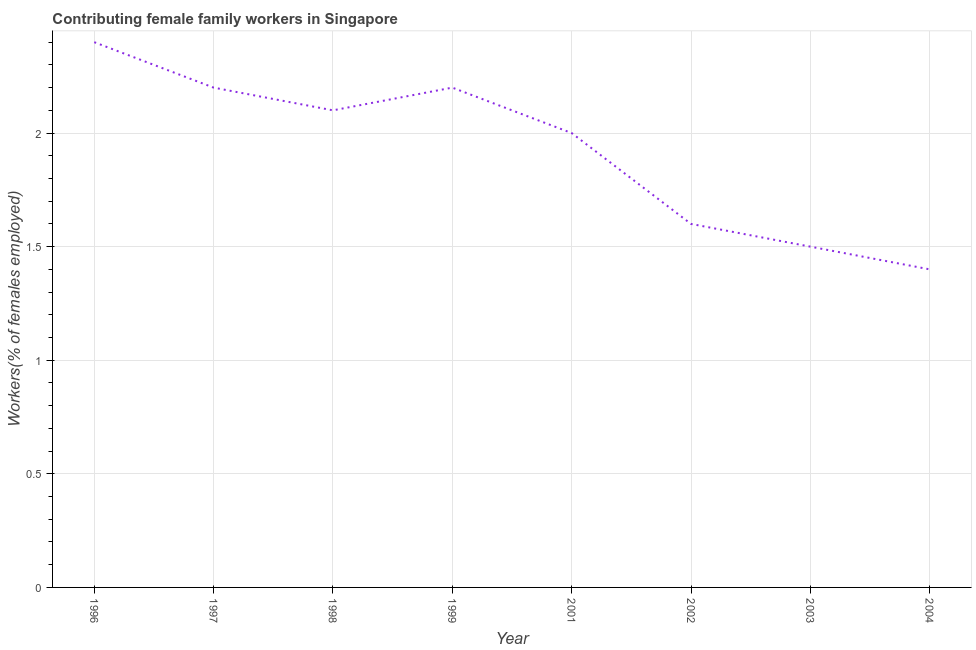What is the contributing female family workers in 1996?
Provide a short and direct response. 2.4. Across all years, what is the maximum contributing female family workers?
Your response must be concise. 2.4. Across all years, what is the minimum contributing female family workers?
Make the answer very short. 1.4. What is the sum of the contributing female family workers?
Give a very brief answer. 15.4. What is the difference between the contributing female family workers in 1997 and 1998?
Your response must be concise. 0.1. What is the average contributing female family workers per year?
Your answer should be very brief. 1.93. What is the median contributing female family workers?
Keep it short and to the point. 2.05. What is the ratio of the contributing female family workers in 1999 to that in 2001?
Offer a very short reply. 1.1. Is the contributing female family workers in 2001 less than that in 2003?
Your response must be concise. No. Is the difference between the contributing female family workers in 1998 and 2004 greater than the difference between any two years?
Provide a short and direct response. No. What is the difference between the highest and the second highest contributing female family workers?
Give a very brief answer. 0.2. What is the difference between the highest and the lowest contributing female family workers?
Offer a terse response. 1. Are the values on the major ticks of Y-axis written in scientific E-notation?
Provide a short and direct response. No. Does the graph contain grids?
Your answer should be very brief. Yes. What is the title of the graph?
Your response must be concise. Contributing female family workers in Singapore. What is the label or title of the X-axis?
Offer a very short reply. Year. What is the label or title of the Y-axis?
Offer a terse response. Workers(% of females employed). What is the Workers(% of females employed) in 1996?
Your answer should be very brief. 2.4. What is the Workers(% of females employed) of 1997?
Give a very brief answer. 2.2. What is the Workers(% of females employed) in 1998?
Give a very brief answer. 2.1. What is the Workers(% of females employed) in 1999?
Offer a terse response. 2.2. What is the Workers(% of females employed) of 2002?
Offer a terse response. 1.6. What is the Workers(% of females employed) of 2004?
Your response must be concise. 1.4. What is the difference between the Workers(% of females employed) in 1996 and 1997?
Provide a short and direct response. 0.2. What is the difference between the Workers(% of females employed) in 1996 and 1998?
Make the answer very short. 0.3. What is the difference between the Workers(% of females employed) in 1996 and 1999?
Ensure brevity in your answer.  0.2. What is the difference between the Workers(% of females employed) in 1996 and 2001?
Give a very brief answer. 0.4. What is the difference between the Workers(% of females employed) in 1996 and 2003?
Your answer should be compact. 0.9. What is the difference between the Workers(% of females employed) in 1997 and 1998?
Offer a very short reply. 0.1. What is the difference between the Workers(% of females employed) in 1997 and 1999?
Ensure brevity in your answer.  0. What is the difference between the Workers(% of females employed) in 1997 and 2002?
Your response must be concise. 0.6. What is the difference between the Workers(% of females employed) in 1998 and 1999?
Offer a very short reply. -0.1. What is the difference between the Workers(% of females employed) in 1998 and 2001?
Give a very brief answer. 0.1. What is the difference between the Workers(% of females employed) in 1998 and 2002?
Your answer should be very brief. 0.5. What is the difference between the Workers(% of females employed) in 1998 and 2004?
Provide a short and direct response. 0.7. What is the difference between the Workers(% of females employed) in 1999 and 2001?
Provide a succinct answer. 0.2. What is the difference between the Workers(% of females employed) in 1999 and 2002?
Offer a terse response. 0.6. What is the difference between the Workers(% of females employed) in 2001 and 2003?
Keep it short and to the point. 0.5. What is the difference between the Workers(% of females employed) in 2002 and 2003?
Your response must be concise. 0.1. What is the difference between the Workers(% of females employed) in 2002 and 2004?
Your response must be concise. 0.2. What is the difference between the Workers(% of females employed) in 2003 and 2004?
Ensure brevity in your answer.  0.1. What is the ratio of the Workers(% of females employed) in 1996 to that in 1997?
Give a very brief answer. 1.09. What is the ratio of the Workers(% of females employed) in 1996 to that in 1998?
Your response must be concise. 1.14. What is the ratio of the Workers(% of females employed) in 1996 to that in 1999?
Provide a short and direct response. 1.09. What is the ratio of the Workers(% of females employed) in 1996 to that in 2001?
Offer a very short reply. 1.2. What is the ratio of the Workers(% of females employed) in 1996 to that in 2003?
Offer a terse response. 1.6. What is the ratio of the Workers(% of females employed) in 1996 to that in 2004?
Your answer should be compact. 1.71. What is the ratio of the Workers(% of females employed) in 1997 to that in 1998?
Ensure brevity in your answer.  1.05. What is the ratio of the Workers(% of females employed) in 1997 to that in 2002?
Provide a succinct answer. 1.38. What is the ratio of the Workers(% of females employed) in 1997 to that in 2003?
Provide a succinct answer. 1.47. What is the ratio of the Workers(% of females employed) in 1997 to that in 2004?
Your answer should be compact. 1.57. What is the ratio of the Workers(% of females employed) in 1998 to that in 1999?
Your response must be concise. 0.95. What is the ratio of the Workers(% of females employed) in 1998 to that in 2001?
Make the answer very short. 1.05. What is the ratio of the Workers(% of females employed) in 1998 to that in 2002?
Make the answer very short. 1.31. What is the ratio of the Workers(% of females employed) in 1999 to that in 2001?
Ensure brevity in your answer.  1.1. What is the ratio of the Workers(% of females employed) in 1999 to that in 2002?
Offer a very short reply. 1.38. What is the ratio of the Workers(% of females employed) in 1999 to that in 2003?
Your answer should be very brief. 1.47. What is the ratio of the Workers(% of females employed) in 1999 to that in 2004?
Give a very brief answer. 1.57. What is the ratio of the Workers(% of females employed) in 2001 to that in 2002?
Keep it short and to the point. 1.25. What is the ratio of the Workers(% of females employed) in 2001 to that in 2003?
Provide a succinct answer. 1.33. What is the ratio of the Workers(% of females employed) in 2001 to that in 2004?
Your answer should be very brief. 1.43. What is the ratio of the Workers(% of females employed) in 2002 to that in 2003?
Your answer should be compact. 1.07. What is the ratio of the Workers(% of females employed) in 2002 to that in 2004?
Provide a short and direct response. 1.14. What is the ratio of the Workers(% of females employed) in 2003 to that in 2004?
Keep it short and to the point. 1.07. 